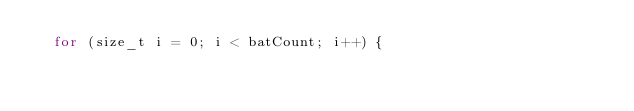<code> <loc_0><loc_0><loc_500><loc_500><_C++_>	for (size_t i = 0; i < batCount; i++) {</code> 